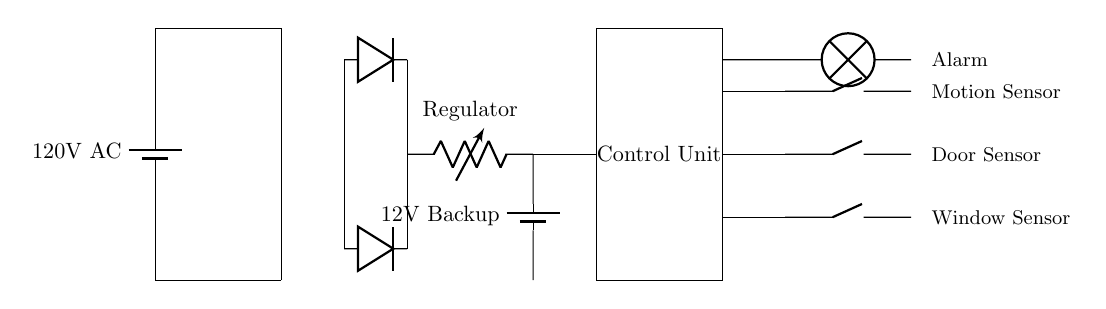What type of rectifier is used in this circuit? The diagram shows two diodes arranged in a configuration that allows current to flow in one direction, characteristic of a full-wave rectifier.
Answer: Full-wave rectifier What is the backup battery voltage in this circuit? The circuit diagram indicates that the backup battery provides a voltage of 12 volts, as labeled next to the battery symbol.
Answer: 12 volts How many sensors are utilized in this security system? The diagram displays three sensors: motion sensor, door sensor, and window sensor, indicating the number of sensors used.
Answer: Three sensors What is the purpose of the voltage regulator? The voltage regulator is indicated in the circuit to ensure that the output voltage remains stable at a specific level, regardless of variations in the input voltage.
Answer: Stabilizing output voltage What happens to the system when the AC power fails? If the 120V AC power supply fails, the circuit is designed to switch to a 12V backup battery, ensuring continuous operation of the control unit and sensors.
Answer: Switch to backup battery Which component activates the alarm in case of a security breach? The circuit connects the control unit directly to the lamp symbol, which represents the alarm. Hence, when any of the sensors detect a breach, the control unit activates the alarm.
Answer: Control unit 